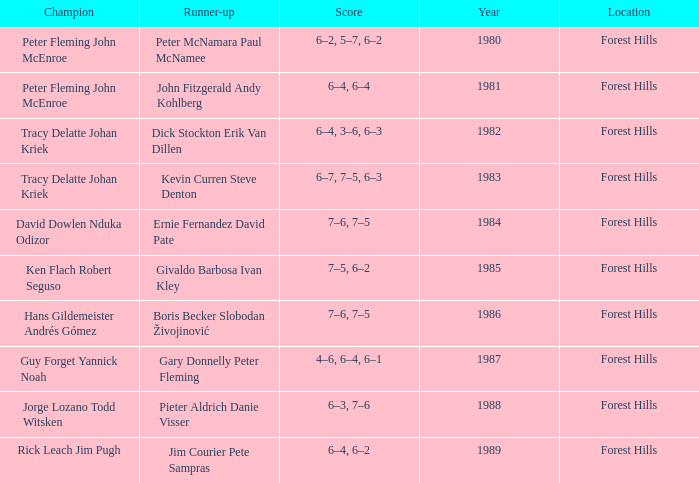Who were the champions in 1988? Jorge Lozano Todd Witsken. 